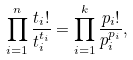<formula> <loc_0><loc_0><loc_500><loc_500>\prod _ { i = 1 } ^ { n } \frac { t _ { i } ! } { t _ { i } ^ { t _ { i } } } = \prod _ { i = 1 } ^ { k } \frac { p _ { i } ! } { p _ { i } ^ { p _ { i } } } ,</formula> 